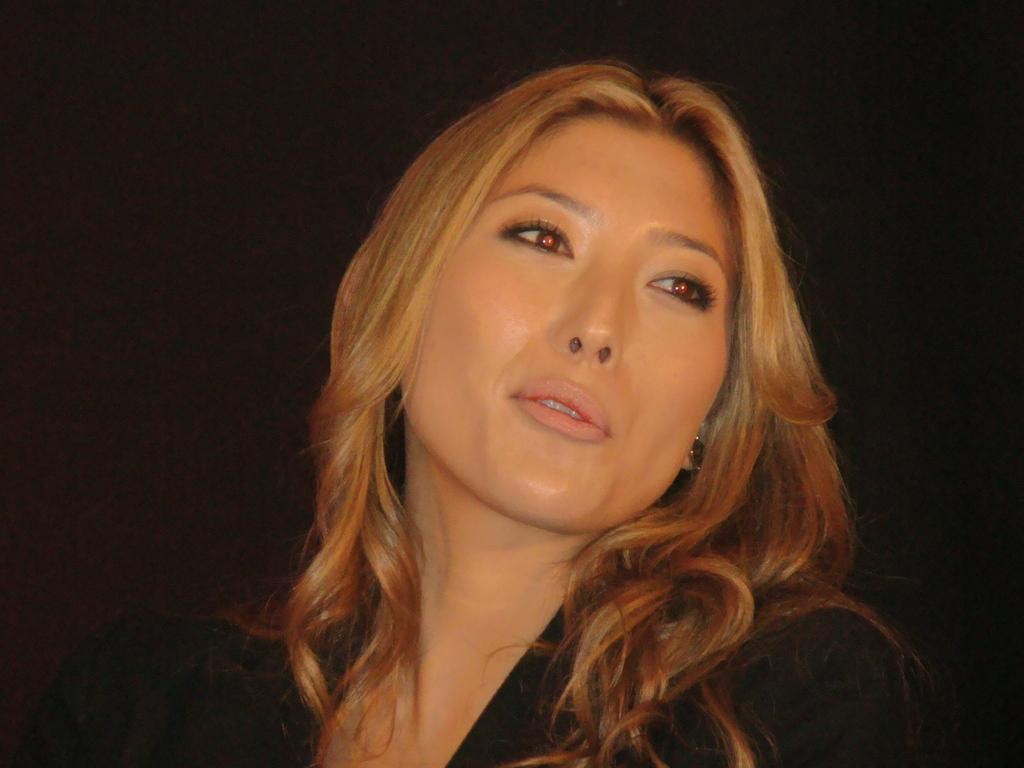What is the main subject of the image? There is a face of a person in the image. What type of friction can be seen between the person's face and the background in the image? There is no friction visible between the person's face and the background in the image, as it is a two-dimensional representation. 